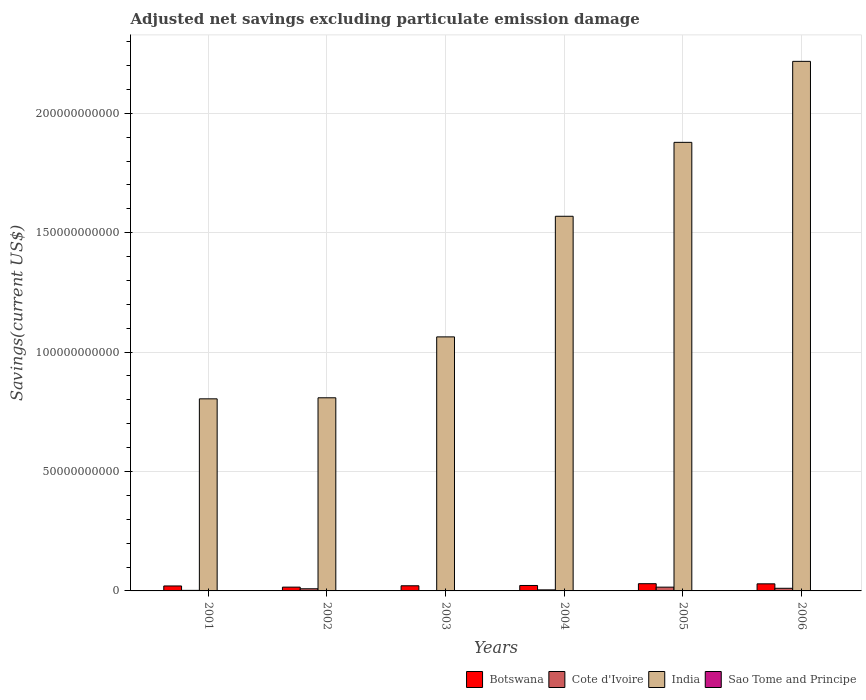How many different coloured bars are there?
Make the answer very short. 4. How many groups of bars are there?
Keep it short and to the point. 6. Are the number of bars per tick equal to the number of legend labels?
Provide a succinct answer. No. Are the number of bars on each tick of the X-axis equal?
Provide a succinct answer. No. How many bars are there on the 6th tick from the left?
Your answer should be very brief. 3. What is the label of the 2nd group of bars from the left?
Provide a succinct answer. 2002. What is the adjusted net savings in Sao Tome and Principe in 2006?
Provide a short and direct response. 0. Across all years, what is the maximum adjusted net savings in Botswana?
Keep it short and to the point. 3.02e+09. Across all years, what is the minimum adjusted net savings in India?
Your response must be concise. 8.04e+1. What is the total adjusted net savings in India in the graph?
Offer a very short reply. 8.34e+11. What is the difference between the adjusted net savings in Cote d'Ivoire in 2004 and that in 2005?
Make the answer very short. -1.14e+09. What is the difference between the adjusted net savings in Cote d'Ivoire in 2001 and the adjusted net savings in Botswana in 2006?
Your response must be concise. -2.74e+09. What is the average adjusted net savings in India per year?
Ensure brevity in your answer.  1.39e+11. In the year 2002, what is the difference between the adjusted net savings in India and adjusted net savings in Botswana?
Your response must be concise. 7.93e+1. In how many years, is the adjusted net savings in Cote d'Ivoire greater than 140000000000 US$?
Keep it short and to the point. 0. What is the ratio of the adjusted net savings in Cote d'Ivoire in 2002 to that in 2005?
Your answer should be very brief. 0.57. Is the difference between the adjusted net savings in India in 2003 and 2004 greater than the difference between the adjusted net savings in Botswana in 2003 and 2004?
Make the answer very short. No. What is the difference between the highest and the second highest adjusted net savings in Cote d'Ivoire?
Make the answer very short. 4.76e+08. What is the difference between the highest and the lowest adjusted net savings in India?
Provide a short and direct response. 1.41e+11. In how many years, is the adjusted net savings in Cote d'Ivoire greater than the average adjusted net savings in Cote d'Ivoire taken over all years?
Provide a short and direct response. 3. Is it the case that in every year, the sum of the adjusted net savings in India and adjusted net savings in Sao Tome and Principe is greater than the sum of adjusted net savings in Botswana and adjusted net savings in Cote d'Ivoire?
Your response must be concise. Yes. How many bars are there?
Ensure brevity in your answer.  18. How many years are there in the graph?
Provide a succinct answer. 6. Are the values on the major ticks of Y-axis written in scientific E-notation?
Offer a very short reply. No. Does the graph contain grids?
Give a very brief answer. Yes. Where does the legend appear in the graph?
Your response must be concise. Bottom right. How are the legend labels stacked?
Provide a short and direct response. Horizontal. What is the title of the graph?
Keep it short and to the point. Adjusted net savings excluding particulate emission damage. Does "European Union" appear as one of the legend labels in the graph?
Provide a short and direct response. No. What is the label or title of the Y-axis?
Your answer should be compact. Savings(current US$). What is the Savings(current US$) of Botswana in 2001?
Ensure brevity in your answer.  2.08e+09. What is the Savings(current US$) in Cote d'Ivoire in 2001?
Offer a very short reply. 2.33e+08. What is the Savings(current US$) in India in 2001?
Offer a terse response. 8.04e+1. What is the Savings(current US$) in Botswana in 2002?
Give a very brief answer. 1.58e+09. What is the Savings(current US$) of Cote d'Ivoire in 2002?
Make the answer very short. 8.99e+08. What is the Savings(current US$) of India in 2002?
Provide a succinct answer. 8.09e+1. What is the Savings(current US$) in Botswana in 2003?
Your answer should be very brief. 2.15e+09. What is the Savings(current US$) in Cote d'Ivoire in 2003?
Your response must be concise. 0. What is the Savings(current US$) of India in 2003?
Keep it short and to the point. 1.06e+11. What is the Savings(current US$) of Sao Tome and Principe in 2003?
Provide a succinct answer. 0. What is the Savings(current US$) of Botswana in 2004?
Your answer should be compact. 2.28e+09. What is the Savings(current US$) of Cote d'Ivoire in 2004?
Provide a succinct answer. 4.42e+08. What is the Savings(current US$) in India in 2004?
Provide a succinct answer. 1.57e+11. What is the Savings(current US$) in Sao Tome and Principe in 2004?
Give a very brief answer. 0. What is the Savings(current US$) of Botswana in 2005?
Provide a succinct answer. 3.02e+09. What is the Savings(current US$) in Cote d'Ivoire in 2005?
Provide a succinct answer. 1.58e+09. What is the Savings(current US$) in India in 2005?
Your response must be concise. 1.88e+11. What is the Savings(current US$) of Sao Tome and Principe in 2005?
Provide a short and direct response. 4.16e+07. What is the Savings(current US$) in Botswana in 2006?
Provide a short and direct response. 2.97e+09. What is the Savings(current US$) of Cote d'Ivoire in 2006?
Your answer should be very brief. 1.10e+09. What is the Savings(current US$) of India in 2006?
Ensure brevity in your answer.  2.22e+11. What is the Savings(current US$) in Sao Tome and Principe in 2006?
Give a very brief answer. 0. Across all years, what is the maximum Savings(current US$) of Botswana?
Keep it short and to the point. 3.02e+09. Across all years, what is the maximum Savings(current US$) in Cote d'Ivoire?
Provide a short and direct response. 1.58e+09. Across all years, what is the maximum Savings(current US$) of India?
Provide a short and direct response. 2.22e+11. Across all years, what is the maximum Savings(current US$) in Sao Tome and Principe?
Your answer should be compact. 4.16e+07. Across all years, what is the minimum Savings(current US$) in Botswana?
Make the answer very short. 1.58e+09. Across all years, what is the minimum Savings(current US$) in India?
Make the answer very short. 8.04e+1. Across all years, what is the minimum Savings(current US$) in Sao Tome and Principe?
Your answer should be very brief. 0. What is the total Savings(current US$) of Botswana in the graph?
Provide a succinct answer. 1.41e+1. What is the total Savings(current US$) of Cote d'Ivoire in the graph?
Ensure brevity in your answer.  4.25e+09. What is the total Savings(current US$) in India in the graph?
Provide a short and direct response. 8.34e+11. What is the total Savings(current US$) of Sao Tome and Principe in the graph?
Keep it short and to the point. 4.16e+07. What is the difference between the Savings(current US$) of Botswana in 2001 and that in 2002?
Provide a short and direct response. 4.96e+08. What is the difference between the Savings(current US$) in Cote d'Ivoire in 2001 and that in 2002?
Your response must be concise. -6.66e+08. What is the difference between the Savings(current US$) in India in 2001 and that in 2002?
Your response must be concise. -4.41e+08. What is the difference between the Savings(current US$) in Botswana in 2001 and that in 2003?
Offer a very short reply. -7.26e+07. What is the difference between the Savings(current US$) of India in 2001 and that in 2003?
Keep it short and to the point. -2.59e+1. What is the difference between the Savings(current US$) in Botswana in 2001 and that in 2004?
Give a very brief answer. -2.01e+08. What is the difference between the Savings(current US$) in Cote d'Ivoire in 2001 and that in 2004?
Your answer should be compact. -2.09e+08. What is the difference between the Savings(current US$) of India in 2001 and that in 2004?
Ensure brevity in your answer.  -7.65e+1. What is the difference between the Savings(current US$) of Botswana in 2001 and that in 2005?
Your response must be concise. -9.43e+08. What is the difference between the Savings(current US$) in Cote d'Ivoire in 2001 and that in 2005?
Provide a short and direct response. -1.34e+09. What is the difference between the Savings(current US$) of India in 2001 and that in 2005?
Offer a terse response. -1.07e+11. What is the difference between the Savings(current US$) of Botswana in 2001 and that in 2006?
Offer a terse response. -8.89e+08. What is the difference between the Savings(current US$) of Cote d'Ivoire in 2001 and that in 2006?
Your response must be concise. -8.68e+08. What is the difference between the Savings(current US$) in India in 2001 and that in 2006?
Your answer should be compact. -1.41e+11. What is the difference between the Savings(current US$) in Botswana in 2002 and that in 2003?
Ensure brevity in your answer.  -5.69e+08. What is the difference between the Savings(current US$) of India in 2002 and that in 2003?
Your answer should be compact. -2.55e+1. What is the difference between the Savings(current US$) of Botswana in 2002 and that in 2004?
Your response must be concise. -6.97e+08. What is the difference between the Savings(current US$) of Cote d'Ivoire in 2002 and that in 2004?
Offer a terse response. 4.57e+08. What is the difference between the Savings(current US$) of India in 2002 and that in 2004?
Make the answer very short. -7.60e+1. What is the difference between the Savings(current US$) of Botswana in 2002 and that in 2005?
Keep it short and to the point. -1.44e+09. What is the difference between the Savings(current US$) in Cote d'Ivoire in 2002 and that in 2005?
Your response must be concise. -6.78e+08. What is the difference between the Savings(current US$) in India in 2002 and that in 2005?
Your answer should be compact. -1.07e+11. What is the difference between the Savings(current US$) of Botswana in 2002 and that in 2006?
Provide a short and direct response. -1.39e+09. What is the difference between the Savings(current US$) in Cote d'Ivoire in 2002 and that in 2006?
Your answer should be compact. -2.02e+08. What is the difference between the Savings(current US$) in India in 2002 and that in 2006?
Your answer should be compact. -1.41e+11. What is the difference between the Savings(current US$) in Botswana in 2003 and that in 2004?
Your answer should be compact. -1.28e+08. What is the difference between the Savings(current US$) of India in 2003 and that in 2004?
Provide a succinct answer. -5.05e+1. What is the difference between the Savings(current US$) in Botswana in 2003 and that in 2005?
Your response must be concise. -8.70e+08. What is the difference between the Savings(current US$) of India in 2003 and that in 2005?
Ensure brevity in your answer.  -8.15e+1. What is the difference between the Savings(current US$) of Botswana in 2003 and that in 2006?
Provide a succinct answer. -8.16e+08. What is the difference between the Savings(current US$) of India in 2003 and that in 2006?
Provide a short and direct response. -1.15e+11. What is the difference between the Savings(current US$) of Botswana in 2004 and that in 2005?
Provide a succinct answer. -7.42e+08. What is the difference between the Savings(current US$) of Cote d'Ivoire in 2004 and that in 2005?
Provide a short and direct response. -1.14e+09. What is the difference between the Savings(current US$) in India in 2004 and that in 2005?
Your answer should be compact. -3.10e+1. What is the difference between the Savings(current US$) in Botswana in 2004 and that in 2006?
Ensure brevity in your answer.  -6.88e+08. What is the difference between the Savings(current US$) in Cote d'Ivoire in 2004 and that in 2006?
Offer a very short reply. -6.59e+08. What is the difference between the Savings(current US$) of India in 2004 and that in 2006?
Your answer should be very brief. -6.49e+1. What is the difference between the Savings(current US$) in Botswana in 2005 and that in 2006?
Provide a succinct answer. 5.38e+07. What is the difference between the Savings(current US$) of Cote d'Ivoire in 2005 and that in 2006?
Give a very brief answer. 4.76e+08. What is the difference between the Savings(current US$) of India in 2005 and that in 2006?
Make the answer very short. -3.39e+1. What is the difference between the Savings(current US$) in Botswana in 2001 and the Savings(current US$) in Cote d'Ivoire in 2002?
Provide a succinct answer. 1.18e+09. What is the difference between the Savings(current US$) of Botswana in 2001 and the Savings(current US$) of India in 2002?
Offer a very short reply. -7.88e+1. What is the difference between the Savings(current US$) of Cote d'Ivoire in 2001 and the Savings(current US$) of India in 2002?
Provide a succinct answer. -8.06e+1. What is the difference between the Savings(current US$) in Botswana in 2001 and the Savings(current US$) in India in 2003?
Ensure brevity in your answer.  -1.04e+11. What is the difference between the Savings(current US$) in Cote d'Ivoire in 2001 and the Savings(current US$) in India in 2003?
Provide a short and direct response. -1.06e+11. What is the difference between the Savings(current US$) of Botswana in 2001 and the Savings(current US$) of Cote d'Ivoire in 2004?
Make the answer very short. 1.64e+09. What is the difference between the Savings(current US$) in Botswana in 2001 and the Savings(current US$) in India in 2004?
Keep it short and to the point. -1.55e+11. What is the difference between the Savings(current US$) of Cote d'Ivoire in 2001 and the Savings(current US$) of India in 2004?
Your response must be concise. -1.57e+11. What is the difference between the Savings(current US$) in Botswana in 2001 and the Savings(current US$) in Cote d'Ivoire in 2005?
Your answer should be very brief. 5.03e+08. What is the difference between the Savings(current US$) in Botswana in 2001 and the Savings(current US$) in India in 2005?
Offer a terse response. -1.86e+11. What is the difference between the Savings(current US$) of Botswana in 2001 and the Savings(current US$) of Sao Tome and Principe in 2005?
Your answer should be compact. 2.04e+09. What is the difference between the Savings(current US$) in Cote d'Ivoire in 2001 and the Savings(current US$) in India in 2005?
Make the answer very short. -1.88e+11. What is the difference between the Savings(current US$) of Cote d'Ivoire in 2001 and the Savings(current US$) of Sao Tome and Principe in 2005?
Give a very brief answer. 1.92e+08. What is the difference between the Savings(current US$) in India in 2001 and the Savings(current US$) in Sao Tome and Principe in 2005?
Provide a short and direct response. 8.04e+1. What is the difference between the Savings(current US$) of Botswana in 2001 and the Savings(current US$) of Cote d'Ivoire in 2006?
Offer a terse response. 9.79e+08. What is the difference between the Savings(current US$) of Botswana in 2001 and the Savings(current US$) of India in 2006?
Offer a very short reply. -2.20e+11. What is the difference between the Savings(current US$) of Cote d'Ivoire in 2001 and the Savings(current US$) of India in 2006?
Your answer should be compact. -2.22e+11. What is the difference between the Savings(current US$) in Botswana in 2002 and the Savings(current US$) in India in 2003?
Your answer should be compact. -1.05e+11. What is the difference between the Savings(current US$) of Cote d'Ivoire in 2002 and the Savings(current US$) of India in 2003?
Ensure brevity in your answer.  -1.05e+11. What is the difference between the Savings(current US$) in Botswana in 2002 and the Savings(current US$) in Cote d'Ivoire in 2004?
Offer a very short reply. 1.14e+09. What is the difference between the Savings(current US$) in Botswana in 2002 and the Savings(current US$) in India in 2004?
Your answer should be compact. -1.55e+11. What is the difference between the Savings(current US$) in Cote d'Ivoire in 2002 and the Savings(current US$) in India in 2004?
Provide a short and direct response. -1.56e+11. What is the difference between the Savings(current US$) of Botswana in 2002 and the Savings(current US$) of Cote d'Ivoire in 2005?
Give a very brief answer. 6.42e+06. What is the difference between the Savings(current US$) in Botswana in 2002 and the Savings(current US$) in India in 2005?
Your response must be concise. -1.86e+11. What is the difference between the Savings(current US$) of Botswana in 2002 and the Savings(current US$) of Sao Tome and Principe in 2005?
Your answer should be very brief. 1.54e+09. What is the difference between the Savings(current US$) of Cote d'Ivoire in 2002 and the Savings(current US$) of India in 2005?
Make the answer very short. -1.87e+11. What is the difference between the Savings(current US$) of Cote d'Ivoire in 2002 and the Savings(current US$) of Sao Tome and Principe in 2005?
Offer a terse response. 8.58e+08. What is the difference between the Savings(current US$) of India in 2002 and the Savings(current US$) of Sao Tome and Principe in 2005?
Offer a terse response. 8.08e+1. What is the difference between the Savings(current US$) in Botswana in 2002 and the Savings(current US$) in Cote d'Ivoire in 2006?
Your answer should be compact. 4.82e+08. What is the difference between the Savings(current US$) in Botswana in 2002 and the Savings(current US$) in India in 2006?
Give a very brief answer. -2.20e+11. What is the difference between the Savings(current US$) in Cote d'Ivoire in 2002 and the Savings(current US$) in India in 2006?
Make the answer very short. -2.21e+11. What is the difference between the Savings(current US$) of Botswana in 2003 and the Savings(current US$) of Cote d'Ivoire in 2004?
Ensure brevity in your answer.  1.71e+09. What is the difference between the Savings(current US$) of Botswana in 2003 and the Savings(current US$) of India in 2004?
Provide a short and direct response. -1.55e+11. What is the difference between the Savings(current US$) of Botswana in 2003 and the Savings(current US$) of Cote d'Ivoire in 2005?
Ensure brevity in your answer.  5.75e+08. What is the difference between the Savings(current US$) in Botswana in 2003 and the Savings(current US$) in India in 2005?
Provide a succinct answer. -1.86e+11. What is the difference between the Savings(current US$) in Botswana in 2003 and the Savings(current US$) in Sao Tome and Principe in 2005?
Provide a short and direct response. 2.11e+09. What is the difference between the Savings(current US$) in India in 2003 and the Savings(current US$) in Sao Tome and Principe in 2005?
Give a very brief answer. 1.06e+11. What is the difference between the Savings(current US$) in Botswana in 2003 and the Savings(current US$) in Cote d'Ivoire in 2006?
Your response must be concise. 1.05e+09. What is the difference between the Savings(current US$) in Botswana in 2003 and the Savings(current US$) in India in 2006?
Offer a terse response. -2.20e+11. What is the difference between the Savings(current US$) in Botswana in 2004 and the Savings(current US$) in Cote d'Ivoire in 2005?
Your response must be concise. 7.04e+08. What is the difference between the Savings(current US$) in Botswana in 2004 and the Savings(current US$) in India in 2005?
Your answer should be very brief. -1.86e+11. What is the difference between the Savings(current US$) of Botswana in 2004 and the Savings(current US$) of Sao Tome and Principe in 2005?
Your answer should be compact. 2.24e+09. What is the difference between the Savings(current US$) in Cote d'Ivoire in 2004 and the Savings(current US$) in India in 2005?
Make the answer very short. -1.87e+11. What is the difference between the Savings(current US$) in Cote d'Ivoire in 2004 and the Savings(current US$) in Sao Tome and Principe in 2005?
Your answer should be compact. 4.01e+08. What is the difference between the Savings(current US$) of India in 2004 and the Savings(current US$) of Sao Tome and Principe in 2005?
Keep it short and to the point. 1.57e+11. What is the difference between the Savings(current US$) in Botswana in 2004 and the Savings(current US$) in Cote d'Ivoire in 2006?
Your answer should be very brief. 1.18e+09. What is the difference between the Savings(current US$) of Botswana in 2004 and the Savings(current US$) of India in 2006?
Your answer should be compact. -2.19e+11. What is the difference between the Savings(current US$) in Cote d'Ivoire in 2004 and the Savings(current US$) in India in 2006?
Give a very brief answer. -2.21e+11. What is the difference between the Savings(current US$) of Botswana in 2005 and the Savings(current US$) of Cote d'Ivoire in 2006?
Ensure brevity in your answer.  1.92e+09. What is the difference between the Savings(current US$) in Botswana in 2005 and the Savings(current US$) in India in 2006?
Your answer should be compact. -2.19e+11. What is the difference between the Savings(current US$) of Cote d'Ivoire in 2005 and the Savings(current US$) of India in 2006?
Provide a short and direct response. -2.20e+11. What is the average Savings(current US$) in Botswana per year?
Ensure brevity in your answer.  2.35e+09. What is the average Savings(current US$) of Cote d'Ivoire per year?
Ensure brevity in your answer.  7.09e+08. What is the average Savings(current US$) of India per year?
Your answer should be compact. 1.39e+11. What is the average Savings(current US$) of Sao Tome and Principe per year?
Provide a succinct answer. 6.94e+06. In the year 2001, what is the difference between the Savings(current US$) of Botswana and Savings(current US$) of Cote d'Ivoire?
Ensure brevity in your answer.  1.85e+09. In the year 2001, what is the difference between the Savings(current US$) in Botswana and Savings(current US$) in India?
Offer a very short reply. -7.84e+1. In the year 2001, what is the difference between the Savings(current US$) in Cote d'Ivoire and Savings(current US$) in India?
Your answer should be compact. -8.02e+1. In the year 2002, what is the difference between the Savings(current US$) of Botswana and Savings(current US$) of Cote d'Ivoire?
Keep it short and to the point. 6.84e+08. In the year 2002, what is the difference between the Savings(current US$) of Botswana and Savings(current US$) of India?
Make the answer very short. -7.93e+1. In the year 2002, what is the difference between the Savings(current US$) of Cote d'Ivoire and Savings(current US$) of India?
Offer a very short reply. -8.00e+1. In the year 2003, what is the difference between the Savings(current US$) in Botswana and Savings(current US$) in India?
Your answer should be compact. -1.04e+11. In the year 2004, what is the difference between the Savings(current US$) in Botswana and Savings(current US$) in Cote d'Ivoire?
Ensure brevity in your answer.  1.84e+09. In the year 2004, what is the difference between the Savings(current US$) of Botswana and Savings(current US$) of India?
Your answer should be compact. -1.55e+11. In the year 2004, what is the difference between the Savings(current US$) of Cote d'Ivoire and Savings(current US$) of India?
Your answer should be very brief. -1.56e+11. In the year 2005, what is the difference between the Savings(current US$) of Botswana and Savings(current US$) of Cote d'Ivoire?
Make the answer very short. 1.45e+09. In the year 2005, what is the difference between the Savings(current US$) of Botswana and Savings(current US$) of India?
Your answer should be very brief. -1.85e+11. In the year 2005, what is the difference between the Savings(current US$) in Botswana and Savings(current US$) in Sao Tome and Principe?
Your answer should be compact. 2.98e+09. In the year 2005, what is the difference between the Savings(current US$) of Cote d'Ivoire and Savings(current US$) of India?
Your answer should be very brief. -1.86e+11. In the year 2005, what is the difference between the Savings(current US$) of Cote d'Ivoire and Savings(current US$) of Sao Tome and Principe?
Your answer should be very brief. 1.54e+09. In the year 2005, what is the difference between the Savings(current US$) in India and Savings(current US$) in Sao Tome and Principe?
Give a very brief answer. 1.88e+11. In the year 2006, what is the difference between the Savings(current US$) in Botswana and Savings(current US$) in Cote d'Ivoire?
Your answer should be compact. 1.87e+09. In the year 2006, what is the difference between the Savings(current US$) of Botswana and Savings(current US$) of India?
Your answer should be compact. -2.19e+11. In the year 2006, what is the difference between the Savings(current US$) in Cote d'Ivoire and Savings(current US$) in India?
Offer a terse response. -2.21e+11. What is the ratio of the Savings(current US$) in Botswana in 2001 to that in 2002?
Your answer should be very brief. 1.31. What is the ratio of the Savings(current US$) in Cote d'Ivoire in 2001 to that in 2002?
Offer a very short reply. 0.26. What is the ratio of the Savings(current US$) in India in 2001 to that in 2002?
Give a very brief answer. 0.99. What is the ratio of the Savings(current US$) of Botswana in 2001 to that in 2003?
Make the answer very short. 0.97. What is the ratio of the Savings(current US$) in India in 2001 to that in 2003?
Provide a succinct answer. 0.76. What is the ratio of the Savings(current US$) of Botswana in 2001 to that in 2004?
Provide a short and direct response. 0.91. What is the ratio of the Savings(current US$) of Cote d'Ivoire in 2001 to that in 2004?
Provide a short and direct response. 0.53. What is the ratio of the Savings(current US$) of India in 2001 to that in 2004?
Your response must be concise. 0.51. What is the ratio of the Savings(current US$) in Botswana in 2001 to that in 2005?
Your answer should be very brief. 0.69. What is the ratio of the Savings(current US$) in Cote d'Ivoire in 2001 to that in 2005?
Your answer should be very brief. 0.15. What is the ratio of the Savings(current US$) in India in 2001 to that in 2005?
Offer a terse response. 0.43. What is the ratio of the Savings(current US$) of Botswana in 2001 to that in 2006?
Keep it short and to the point. 0.7. What is the ratio of the Savings(current US$) in Cote d'Ivoire in 2001 to that in 2006?
Ensure brevity in your answer.  0.21. What is the ratio of the Savings(current US$) in India in 2001 to that in 2006?
Your response must be concise. 0.36. What is the ratio of the Savings(current US$) of Botswana in 2002 to that in 2003?
Your answer should be very brief. 0.74. What is the ratio of the Savings(current US$) in India in 2002 to that in 2003?
Offer a very short reply. 0.76. What is the ratio of the Savings(current US$) in Botswana in 2002 to that in 2004?
Provide a succinct answer. 0.69. What is the ratio of the Savings(current US$) in Cote d'Ivoire in 2002 to that in 2004?
Make the answer very short. 2.03. What is the ratio of the Savings(current US$) in India in 2002 to that in 2004?
Your answer should be very brief. 0.52. What is the ratio of the Savings(current US$) of Botswana in 2002 to that in 2005?
Make the answer very short. 0.52. What is the ratio of the Savings(current US$) of Cote d'Ivoire in 2002 to that in 2005?
Give a very brief answer. 0.57. What is the ratio of the Savings(current US$) of India in 2002 to that in 2005?
Give a very brief answer. 0.43. What is the ratio of the Savings(current US$) in Botswana in 2002 to that in 2006?
Provide a succinct answer. 0.53. What is the ratio of the Savings(current US$) of Cote d'Ivoire in 2002 to that in 2006?
Make the answer very short. 0.82. What is the ratio of the Savings(current US$) of India in 2002 to that in 2006?
Make the answer very short. 0.36. What is the ratio of the Savings(current US$) of Botswana in 2003 to that in 2004?
Your answer should be very brief. 0.94. What is the ratio of the Savings(current US$) of India in 2003 to that in 2004?
Offer a terse response. 0.68. What is the ratio of the Savings(current US$) of Botswana in 2003 to that in 2005?
Your response must be concise. 0.71. What is the ratio of the Savings(current US$) in India in 2003 to that in 2005?
Provide a succinct answer. 0.57. What is the ratio of the Savings(current US$) in Botswana in 2003 to that in 2006?
Make the answer very short. 0.72. What is the ratio of the Savings(current US$) of India in 2003 to that in 2006?
Your answer should be compact. 0.48. What is the ratio of the Savings(current US$) in Botswana in 2004 to that in 2005?
Provide a short and direct response. 0.75. What is the ratio of the Savings(current US$) in Cote d'Ivoire in 2004 to that in 2005?
Give a very brief answer. 0.28. What is the ratio of the Savings(current US$) of India in 2004 to that in 2005?
Ensure brevity in your answer.  0.84. What is the ratio of the Savings(current US$) in Botswana in 2004 to that in 2006?
Your response must be concise. 0.77. What is the ratio of the Savings(current US$) of Cote d'Ivoire in 2004 to that in 2006?
Give a very brief answer. 0.4. What is the ratio of the Savings(current US$) of India in 2004 to that in 2006?
Provide a short and direct response. 0.71. What is the ratio of the Savings(current US$) in Botswana in 2005 to that in 2006?
Ensure brevity in your answer.  1.02. What is the ratio of the Savings(current US$) of Cote d'Ivoire in 2005 to that in 2006?
Offer a terse response. 1.43. What is the ratio of the Savings(current US$) in India in 2005 to that in 2006?
Ensure brevity in your answer.  0.85. What is the difference between the highest and the second highest Savings(current US$) in Botswana?
Give a very brief answer. 5.38e+07. What is the difference between the highest and the second highest Savings(current US$) of Cote d'Ivoire?
Ensure brevity in your answer.  4.76e+08. What is the difference between the highest and the second highest Savings(current US$) of India?
Offer a terse response. 3.39e+1. What is the difference between the highest and the lowest Savings(current US$) in Botswana?
Keep it short and to the point. 1.44e+09. What is the difference between the highest and the lowest Savings(current US$) in Cote d'Ivoire?
Offer a very short reply. 1.58e+09. What is the difference between the highest and the lowest Savings(current US$) of India?
Your answer should be very brief. 1.41e+11. What is the difference between the highest and the lowest Savings(current US$) in Sao Tome and Principe?
Your response must be concise. 4.16e+07. 